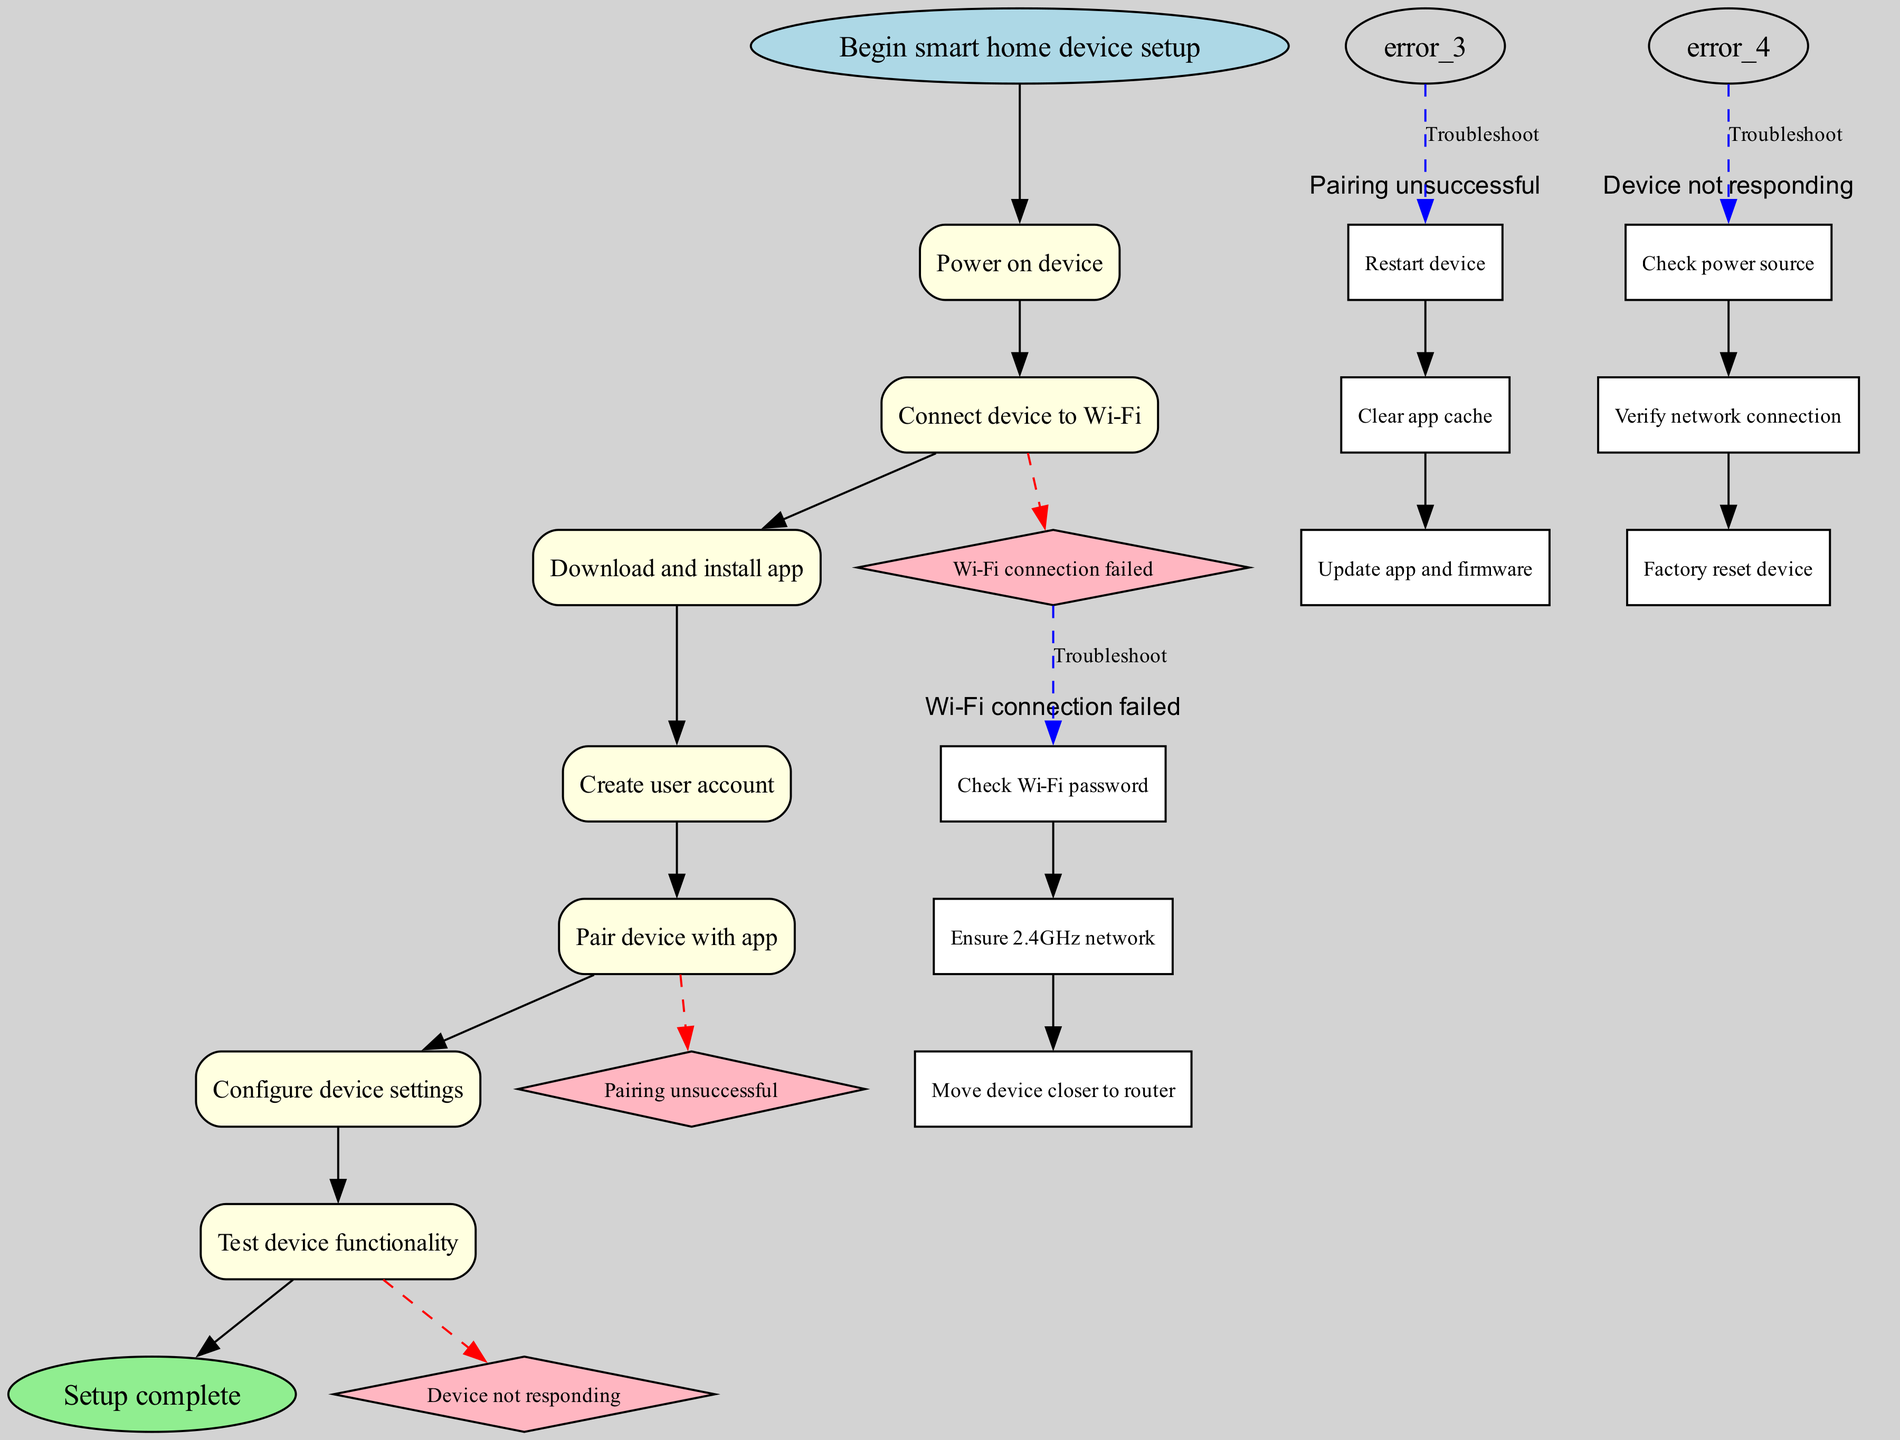What is the first step in the setup process? The first step in the diagram is represented by node '1', which states "Power on device". Thus, the process begins with this action.
Answer: Power on device How many main steps are there in the setup process? By counting the nodes representing the main steps in the diagram, we see there are a total of 7 steps before reaching the end node.
Answer: 7 What happens if the Wi-Fi connection fails? The diagram shows that if the Wi-Fi connection fails (indicated by an error node), the user is suggested to perform a series of troubleshooting steps including checking the Wi-Fi password and moving the device closer to the router.
Answer: Troubleshooting steps What is the outcome if the device is not responding during testing? If the device is not responding at the testing stage, the diagram indicates that the user should perform troubleshooting steps to check the power source and verify network connection, pointing towards potential problems.
Answer: Troubleshooting steps After creating a user account, what is the next step? Following the creation of a user account (shown in node '4'), the flow indicates that the very next step is to "Pair device with app".
Answer: Pair device with app How can a user resolve an unsuccessful pairing? If pairing is unsuccessful, the troubleshooting section provides specific steps: restarting the device, clearing the app cache, or updating the app and firmware to potentially fix the issue.
Answer: Troubleshooting steps What is the last step of the setup process? The final part of the diagram specifies that the last step is represented by the end node, stating "Setup complete", which concludes the setup process.
Answer: Setup complete Which network frequency does the device need to connect to? The diagram highlights in the Wi-Fi connection error section that the device must connect to a 2.4GHz network, indicating the specific frequency required.
Answer: 2.4GHz network How are errors indicated in the diagram? In the flow chart, errors are represented by diamond-shaped nodes, which are connected by dashed edges from the main steps, differentiating them from the regular step nodes.
Answer: Diamond-shaped nodes What is the purpose of the troubleshooting steps in the diagram? The troubleshooting steps provide a solution path for users to follow when encountering errors such as Wi-Fi connection failure or device not responding, ensuring users have guidance to resolve issues.
Answer: Solution path for errors 